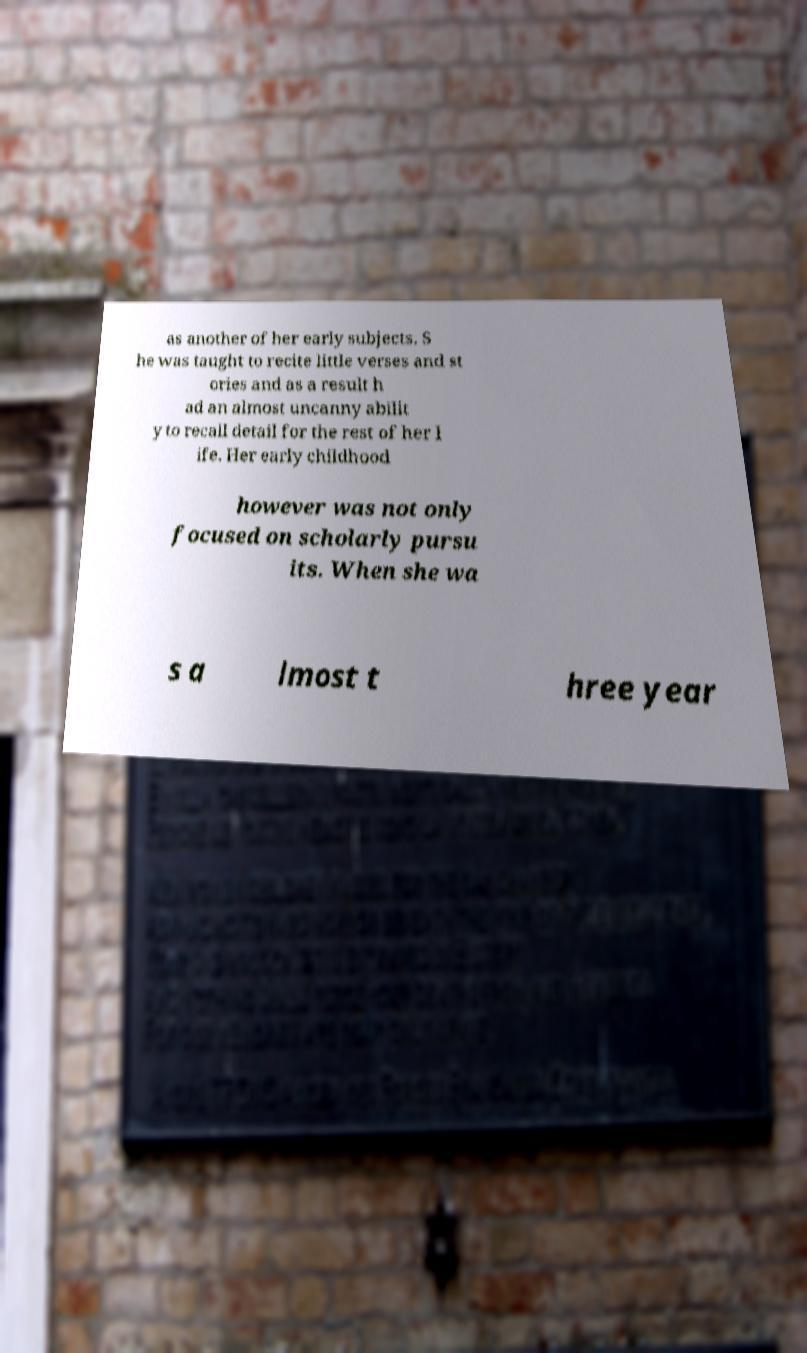Please read and relay the text visible in this image. What does it say? as another of her early subjects. S he was taught to recite little verses and st ories and as a result h ad an almost uncanny abilit y to recall detail for the rest of her l ife. Her early childhood however was not only focused on scholarly pursu its. When she wa s a lmost t hree year 